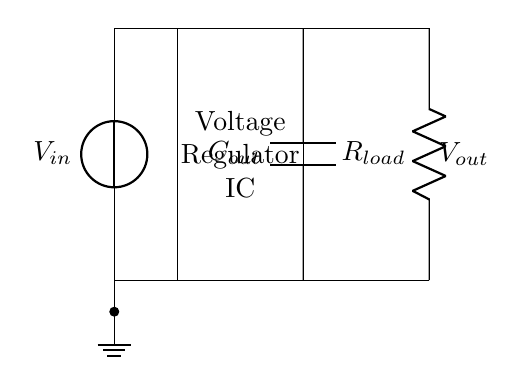What is the purpose of the voltage regulator? The voltage regulator maintains a stable output voltage (Vout) regardless of changes in input voltage (Vin) or load conditions. In smart home devices, this is crucial for preventing damage and ensuring reliable operation.
Answer: Stable output voltage What type of capacitor is shown in the circuit? The circuit diagram includes an output capacitor labeled Cout, which helps smooth the output voltage by filtering out noise and stabilizing the voltage level, crucial for the performance of electronic devices.
Answer: Output capacitor What does Rload represent? Rload represents the load resistor connected to the output of the voltage regulator, simulating the devices that would use the regulated voltage in a smart home setup.
Answer: Load resistor Where is the ground connection located? The ground connection is at the bottom of the circuit, specifically where the input voltage source connects to a ground node. This serves as a reference point for the circuit's voltage levels.
Answer: Bottom of the circuit What is Vout in relation to Vin? Vout is the regulated voltage output that is typically lower than Vin, designed to be consistent for circuit operation. This regulation is crucial in ensuring devices receive the correct voltage.
Answer: Lower than Vin How does a voltage regulator affect device performance? A voltage regulator stabilizes voltage levels, preventing fluctuations that could lead to device malfunction or damage. Consistent power supply ensures optimal performance of smart home devices.
Answer: Optimizes performance 